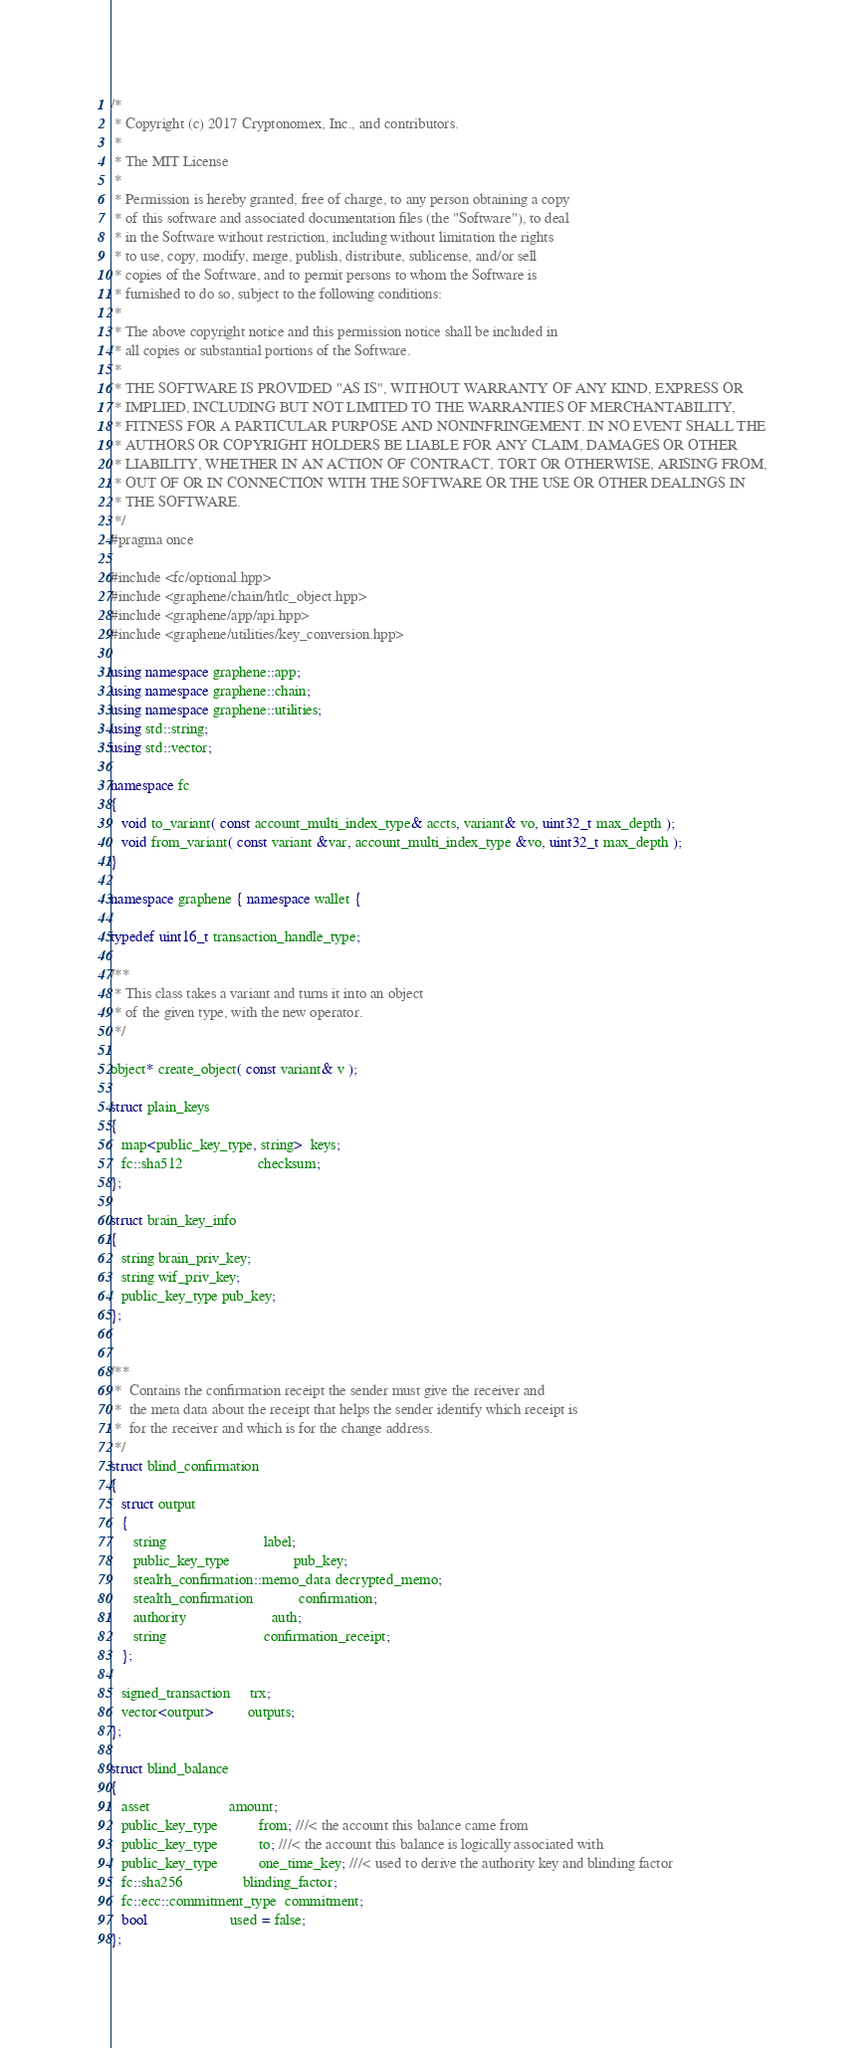Convert code to text. <code><loc_0><loc_0><loc_500><loc_500><_C++_>/*
 * Copyright (c) 2017 Cryptonomex, Inc., and contributors.
 *
 * The MIT License
 *
 * Permission is hereby granted, free of charge, to any person obtaining a copy
 * of this software and associated documentation files (the "Software"), to deal
 * in the Software without restriction, including without limitation the rights
 * to use, copy, modify, merge, publish, distribute, sublicense, and/or sell
 * copies of the Software, and to permit persons to whom the Software is
 * furnished to do so, subject to the following conditions:
 *
 * The above copyright notice and this permission notice shall be included in
 * all copies or substantial portions of the Software.
 *
 * THE SOFTWARE IS PROVIDED "AS IS", WITHOUT WARRANTY OF ANY KIND, EXPRESS OR
 * IMPLIED, INCLUDING BUT NOT LIMITED TO THE WARRANTIES OF MERCHANTABILITY,
 * FITNESS FOR A PARTICULAR PURPOSE AND NONINFRINGEMENT. IN NO EVENT SHALL THE
 * AUTHORS OR COPYRIGHT HOLDERS BE LIABLE FOR ANY CLAIM, DAMAGES OR OTHER
 * LIABILITY, WHETHER IN AN ACTION OF CONTRACT, TORT OR OTHERWISE, ARISING FROM,
 * OUT OF OR IN CONNECTION WITH THE SOFTWARE OR THE USE OR OTHER DEALINGS IN
 * THE SOFTWARE.
 */
#pragma once

#include <fc/optional.hpp>
#include <graphene/chain/htlc_object.hpp>
#include <graphene/app/api.hpp>
#include <graphene/utilities/key_conversion.hpp>

using namespace graphene::app;
using namespace graphene::chain;
using namespace graphene::utilities;
using std::string;
using std::vector;

namespace fc
{
   void to_variant( const account_multi_index_type& accts, variant& vo, uint32_t max_depth );
   void from_variant( const variant &var, account_multi_index_type &vo, uint32_t max_depth );
}

namespace graphene { namespace wallet {

typedef uint16_t transaction_handle_type;

/**
 * This class takes a variant and turns it into an object
 * of the given type, with the new operator.
 */

object* create_object( const variant& v );

struct plain_keys
{
   map<public_key_type, string>  keys;
   fc::sha512                    checksum;
};

struct brain_key_info
{
   string brain_priv_key;
   string wif_priv_key;
   public_key_type pub_key;
};


/**
 *  Contains the confirmation receipt the sender must give the receiver and
 *  the meta data about the receipt that helps the sender identify which receipt is
 *  for the receiver and which is for the change address.
 */
struct blind_confirmation
{
   struct output
   {
      string                          label;
      public_key_type                 pub_key;
      stealth_confirmation::memo_data decrypted_memo;
      stealth_confirmation            confirmation;
      authority                       auth;
      string                          confirmation_receipt;
   };

   signed_transaction     trx;
   vector<output>         outputs;
};

struct blind_balance
{
   asset                     amount;
   public_key_type           from; ///< the account this balance came from
   public_key_type           to; ///< the account this balance is logically associated with
   public_key_type           one_time_key; ///< used to derive the authority key and blinding factor
   fc::sha256                blinding_factor;
   fc::ecc::commitment_type  commitment;
   bool                      used = false;
};
</code> 